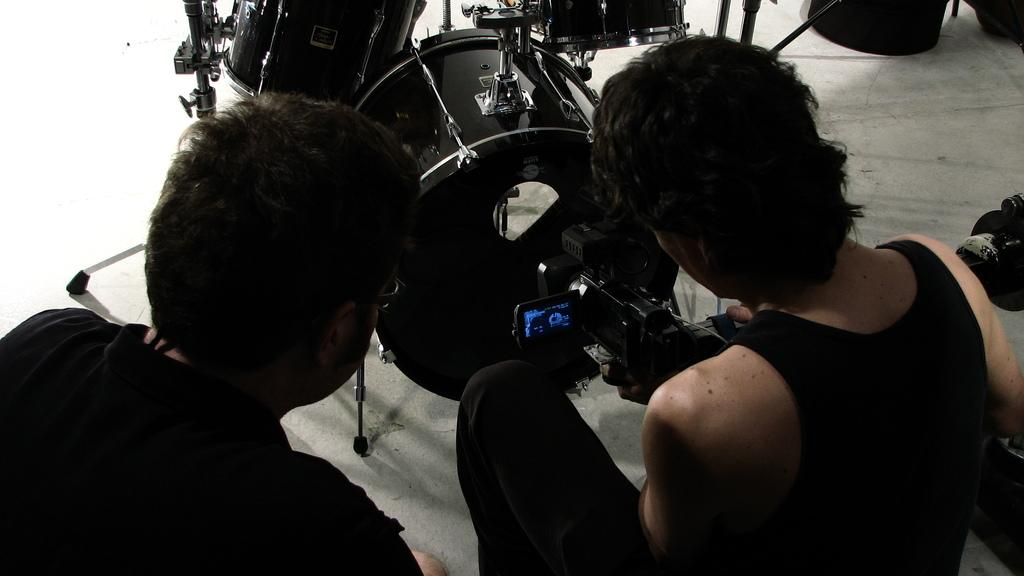How many people are in the image? There are two people in the image. What is the person on the right holding? The person on the right is holding a camera. Can you describe anything in the background of the image? Yes, there is a musical instrument in the background of the image. What type of hole can be seen in the image? There is no hole present in the image. How does the shade affect the people in the image? There is no mention of a shade or any effect it might have on the people in the image. 